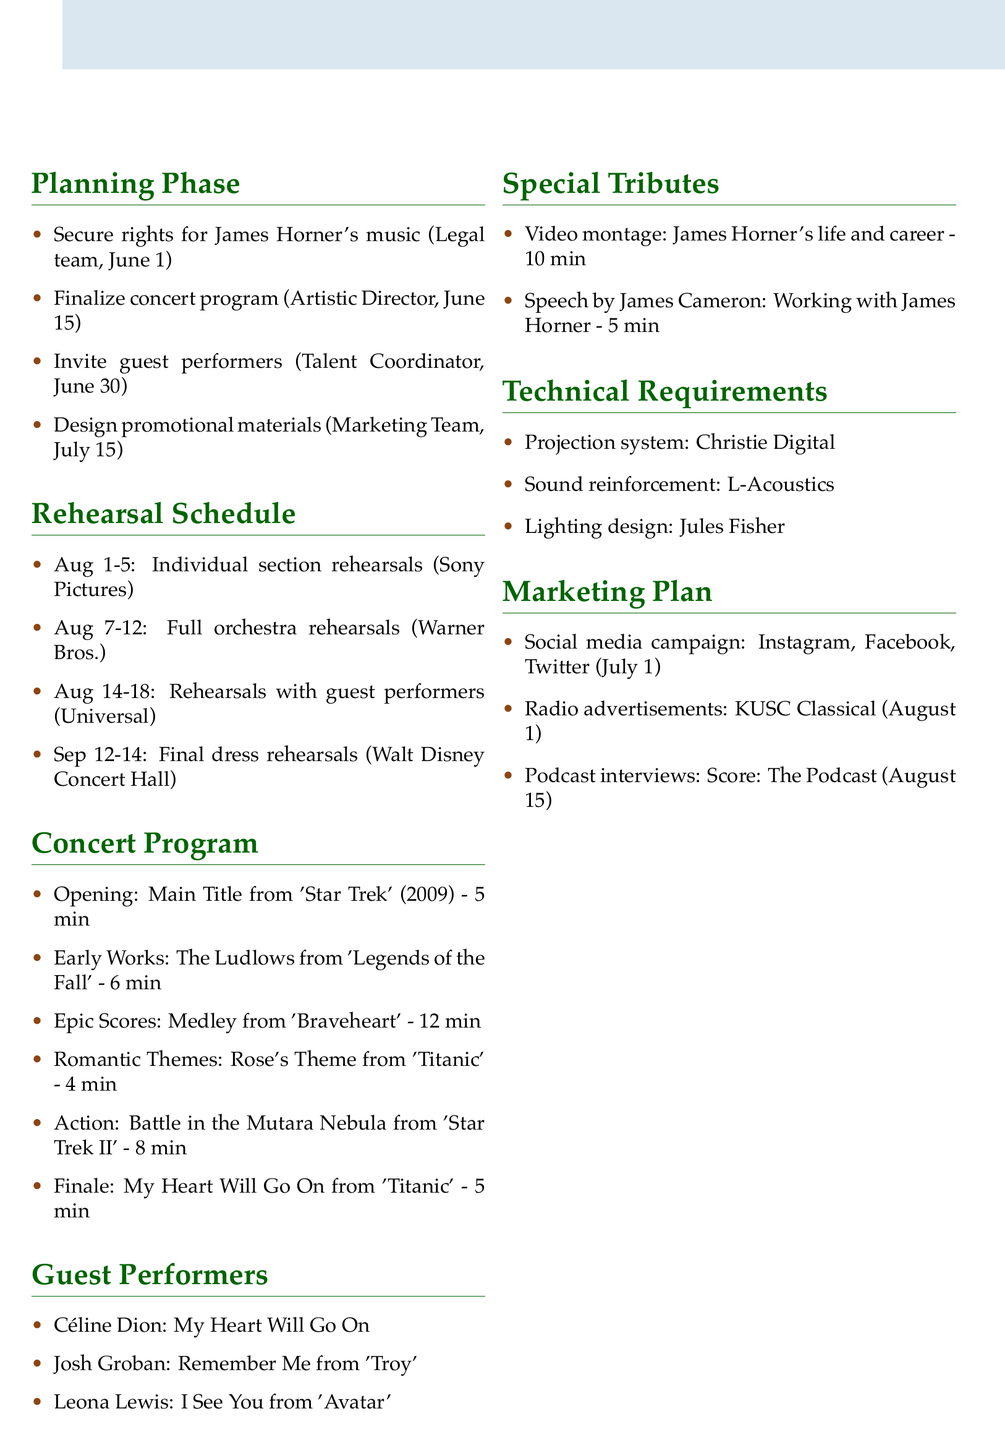What is the title of the concert? The title of the concert is prominently displayed at the top of the document as "A Tribute to James Horner: Maestro of Emotion."
Answer: A Tribute to James Horner: Maestro of Emotion What is the date of the concert? The date of the concert is stated in the header section of the document as September 15, 2023.
Answer: September 15, 2023 Who is responsible for inviting guest performers? This information can be found in the planning phase section where roles are assigned to tasks. The Talent Coordinator is responsible.
Answer: Talent Coordinator How many minutes is the medley from 'Braveheart'? The duration of the medley from 'Braveheart' is listed in the concert program section.
Answer: 12 minutes What are the names of the guest performers? The guest performers are explicitly listed in the document, allowing for easy retrieval of names.
Answer: Céline Dion, Josh Groban, Leona Lewis What is the location of the final dress rehearsals? The location for final dress rehearsals is provided in the rehearsal schedule section of the document.
Answer: Walt Disney Concert Hall Which item is provided by Christie Digital? The technical requirements outline the items and their providers, making it clear that Christie Digital provides the projection system.
Answer: Projection system When does the social media campaign start? The start date for the social media campaign is indicated in the marketing plan section.
Answer: July 1, 2023 